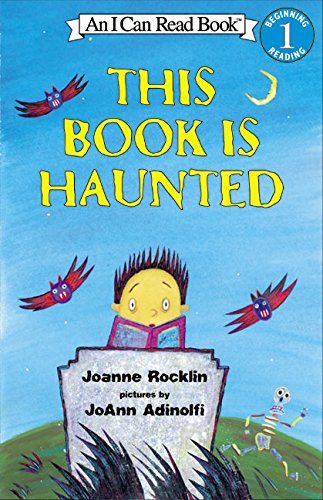Is this a kids book? Yes, it is a children's book, tailored to captivate and educate young minds with simple text and vibrant illustrations. 